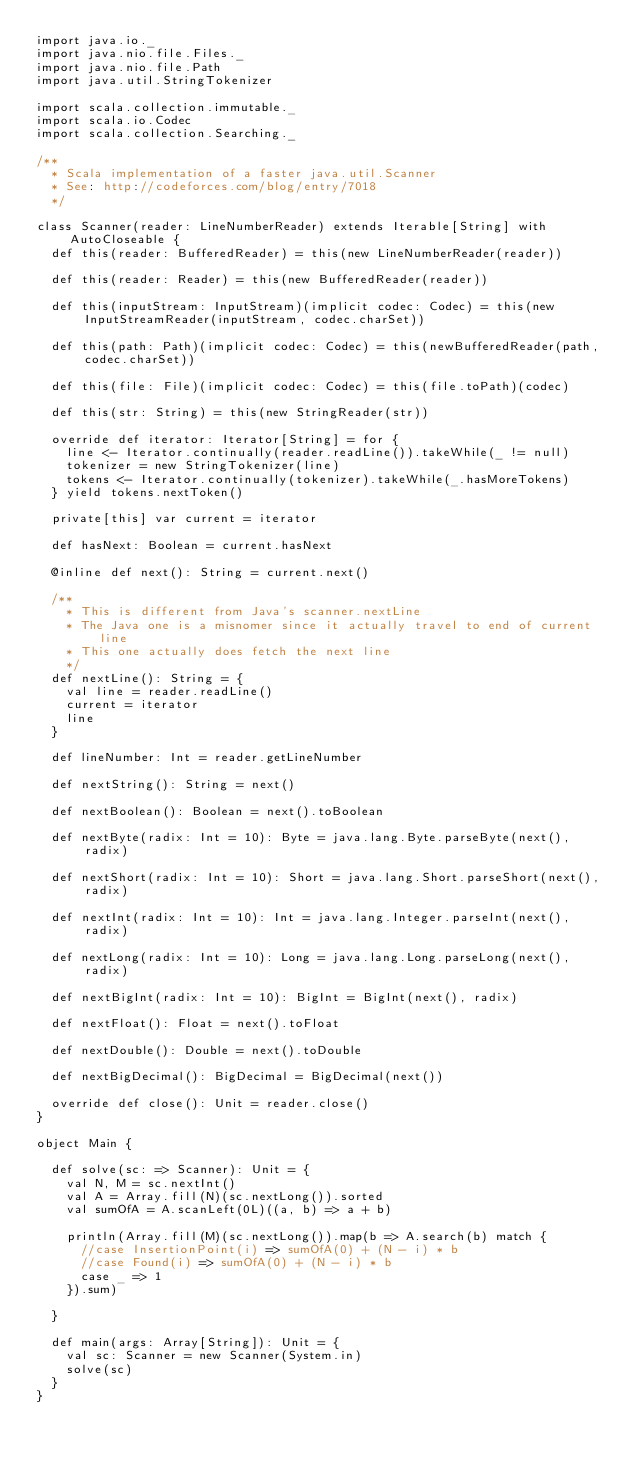<code> <loc_0><loc_0><loc_500><loc_500><_Scala_>import java.io._
import java.nio.file.Files._
import java.nio.file.Path
import java.util.StringTokenizer
  
import scala.collection.immutable._
import scala.io.Codec
import scala.collection.Searching._
  
/**
  * Scala implementation of a faster java.util.Scanner
  * See: http://codeforces.com/blog/entry/7018
  */
  
class Scanner(reader: LineNumberReader) extends Iterable[String] with AutoCloseable {
  def this(reader: BufferedReader) = this(new LineNumberReader(reader))
  
  def this(reader: Reader) = this(new BufferedReader(reader))
  
  def this(inputStream: InputStream)(implicit codec: Codec) = this(new InputStreamReader(inputStream, codec.charSet))
  
  def this(path: Path)(implicit codec: Codec) = this(newBufferedReader(path, codec.charSet))
  
  def this(file: File)(implicit codec: Codec) = this(file.toPath)(codec)
  
  def this(str: String) = this(new StringReader(str))
  
  override def iterator: Iterator[String] = for {
    line <- Iterator.continually(reader.readLine()).takeWhile(_ != null)
    tokenizer = new StringTokenizer(line)
    tokens <- Iterator.continually(tokenizer).takeWhile(_.hasMoreTokens)
  } yield tokens.nextToken()
  
  private[this] var current = iterator
  
  def hasNext: Boolean = current.hasNext
  
  @inline def next(): String = current.next()
  
  /**
    * This is different from Java's scanner.nextLine
    * The Java one is a misnomer since it actually travel to end of current line
    * This one actually does fetch the next line
    */
  def nextLine(): String = {
    val line = reader.readLine()
    current = iterator
    line
  }
  
  def lineNumber: Int = reader.getLineNumber
  
  def nextString(): String = next()
  
  def nextBoolean(): Boolean = next().toBoolean
  
  def nextByte(radix: Int = 10): Byte = java.lang.Byte.parseByte(next(), radix)
  
  def nextShort(radix: Int = 10): Short = java.lang.Short.parseShort(next(), radix)
  
  def nextInt(radix: Int = 10): Int = java.lang.Integer.parseInt(next(), radix)
  
  def nextLong(radix: Int = 10): Long = java.lang.Long.parseLong(next(), radix)
  
  def nextBigInt(radix: Int = 10): BigInt = BigInt(next(), radix)
  
  def nextFloat(): Float = next().toFloat
  
  def nextDouble(): Double = next().toDouble
  
  def nextBigDecimal(): BigDecimal = BigDecimal(next())
  
  override def close(): Unit = reader.close()
}
  
object Main {
  
  def solve(sc: => Scanner): Unit = {
    val N, M = sc.nextInt()
    val A = Array.fill(N)(sc.nextLong()).sorted
    val sumOfA = A.scanLeft(0L)((a, b) => a + b)
 
    println(Array.fill(M)(sc.nextLong()).map(b => A.search(b) match {
      //case InsertionPoint(i) => sumOfA(0) + (N - i) * b
      //case Found(i) => sumOfA(0) + (N - i) * b
      case _ => 1
    }).sum)
     
  }
  
  def main(args: Array[String]): Unit = {
    val sc: Scanner = new Scanner(System.in)
    solve(sc)
  }
}
</code> 